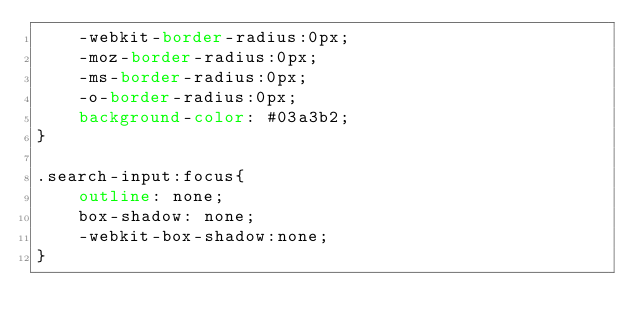Convert code to text. <code><loc_0><loc_0><loc_500><loc_500><_CSS_>    -webkit-border-radius:0px;
    -moz-border-radius:0px;
    -ms-border-radius:0px;
    -o-border-radius:0px;
    background-color: #03a3b2;
}

.search-input:focus{
    outline: none;
    box-shadow: none;
    -webkit-box-shadow:none;
}
</code> 